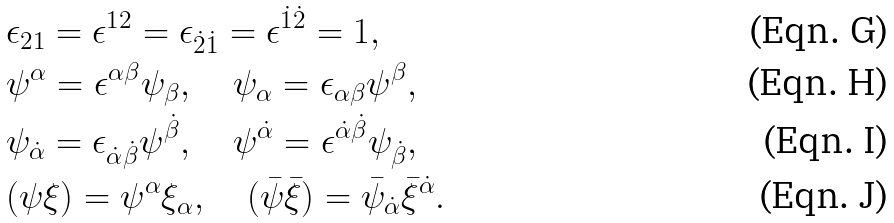<formula> <loc_0><loc_0><loc_500><loc_500>& \epsilon _ { 2 1 } = \epsilon ^ { 1 2 } = \epsilon _ { \dot { 2 } \dot { 1 } } = \epsilon ^ { \dot { 1 } \dot { 2 } } = 1 , \\ & \psi ^ { \alpha } = \epsilon ^ { \alpha \beta } \psi _ { \beta } , \quad \psi _ { \alpha } = \epsilon _ { \alpha \beta } \psi ^ { \beta } , \\ & \psi _ { \dot { \alpha } } = \epsilon _ { \dot { \alpha } \dot { \beta } } \psi ^ { \dot { \beta } } , \quad \psi ^ { \dot { \alpha } } = \epsilon ^ { \dot { \alpha } \dot { \beta } } \psi _ { \dot { \beta } } , \\ & ( \psi \xi ) = \psi ^ { \alpha } \xi _ { \alpha } , \quad ( \bar { \psi } \bar { \xi } ) = \bar { \psi } _ { \dot { \alpha } } \bar { \xi } ^ { \dot { \alpha } } .</formula> 